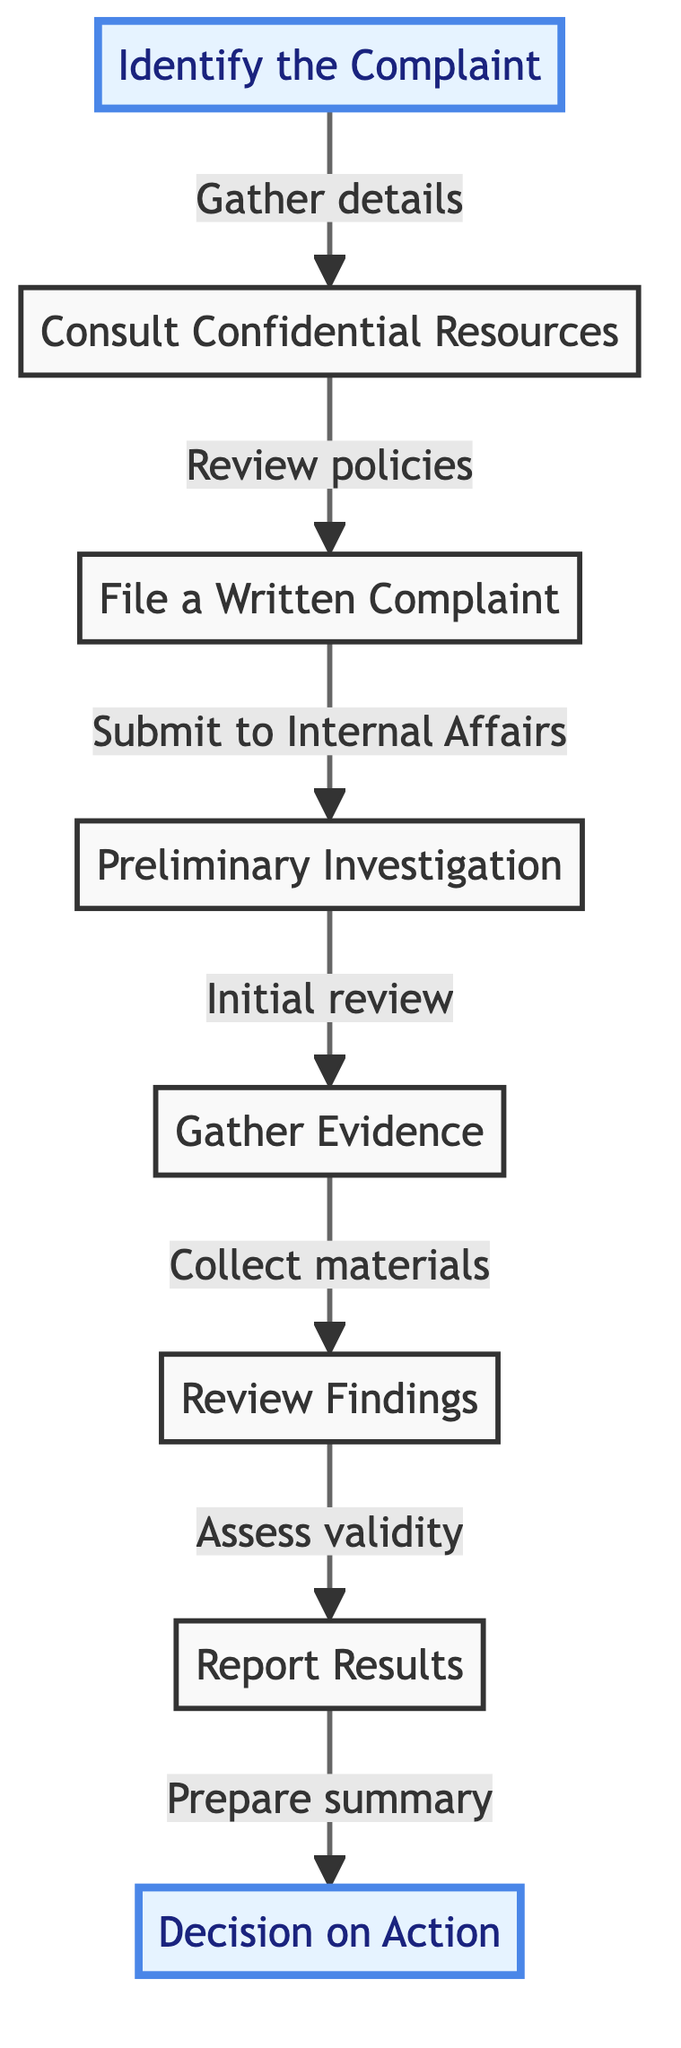What is the first step in the complaint documentation process? The diagram shows that the first step is to "Identify the Complaint" with the description of gathering details regarding the alleged misconduct.
Answer: Identify the Complaint How many main steps are there in the process? By counting the numbered elements in the diagram, we find there are eight main steps that form the procedure.
Answer: 8 What is the last step of the flow chart? The flow chart indicates that the last step is "Decision on Action," which involves the district attorney deciding on the measures based on the report.
Answer: Decision on Action What action follows the "File a Written Complaint"? The diagram illustrates that after filing a written complaint, the next action is the "Preliminary Investigation" conducted by Internal Affairs.
Answer: Preliminary Investigation Which two steps involve assessing and reviewing evidence? The steps that involve assessing and reviewing evidence are "Gather Evidence," which involves collecting materials, and "Review Findings," which assesses the gathered evidence's validity.
Answer: Gather Evidence and Review Findings Which node indicates the need for internal resources? The node that indicates the need for internal resources is "Consult Confidential Resources," referring to internal policies about whistleblowing and confidentiality.
Answer: Consult Confidential Resources What step comes before "Report Results"? The step that comes before "Report Results" is "Review Findings," where the evidence gathered is assessed to determine the validity of the complaint.
Answer: Review Findings What is the primary focus of the "Preliminary Investigation"? The primary focus of the "Preliminary Investigation" step is an "Initial review" of the complaint to evaluate its legitimacy.
Answer: Initial review Is "Gather Evidence" before or after "File a Written Complaint"? According to the flow chart, "Gather Evidence" occurs after "File a Written Complaint," following the preliminary investigation step.
Answer: After 